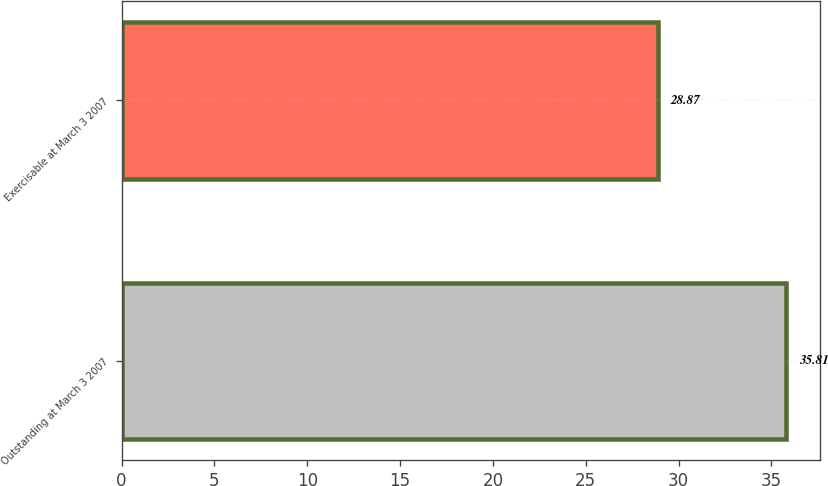<chart> <loc_0><loc_0><loc_500><loc_500><bar_chart><fcel>Outstanding at March 3 2007<fcel>Exercisable at March 3 2007<nl><fcel>35.81<fcel>28.87<nl></chart> 